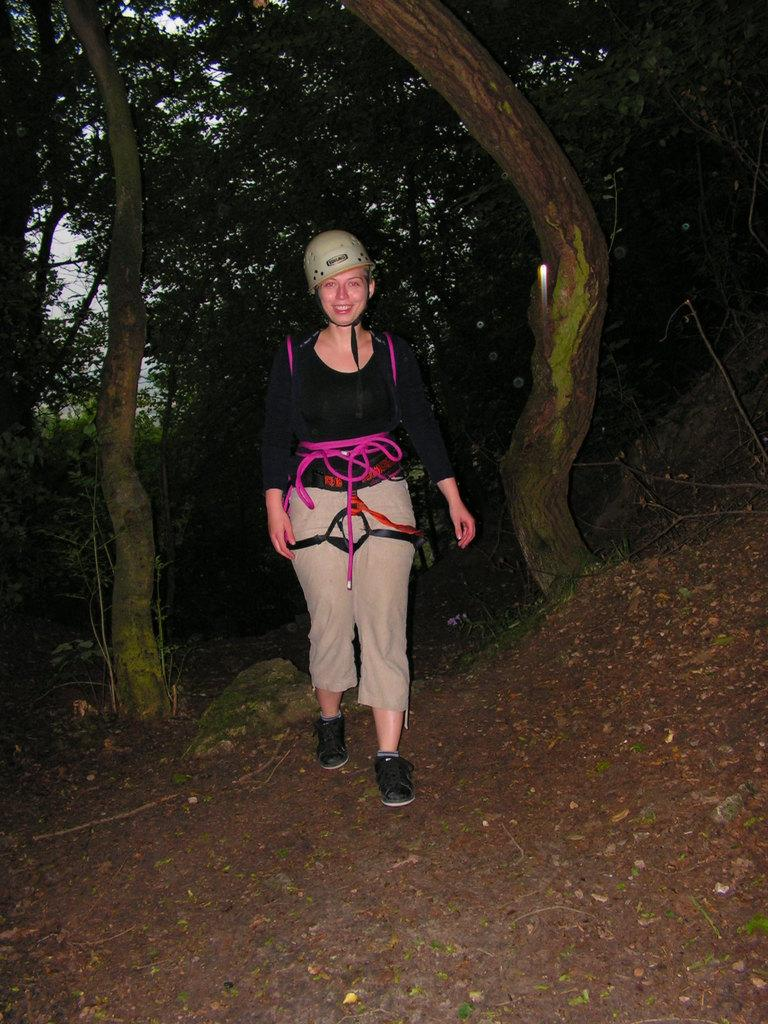Who is the main subject in the picture? There is a woman in the center of the picture. What is the woman wearing? The woman is wearing a backpack and helmet. What is the woman doing in the image? The woman is walking. What can be seen in the foreground of the image? Dry leaves and soil are present in the foreground. What is visible in the background of the image? There are trees in the background. How would you describe the lighting in the image? The image appears to be dark. What type of song is the woman singing in the image? There is no indication in the image that the woman is singing, so it cannot be determined from the picture. 